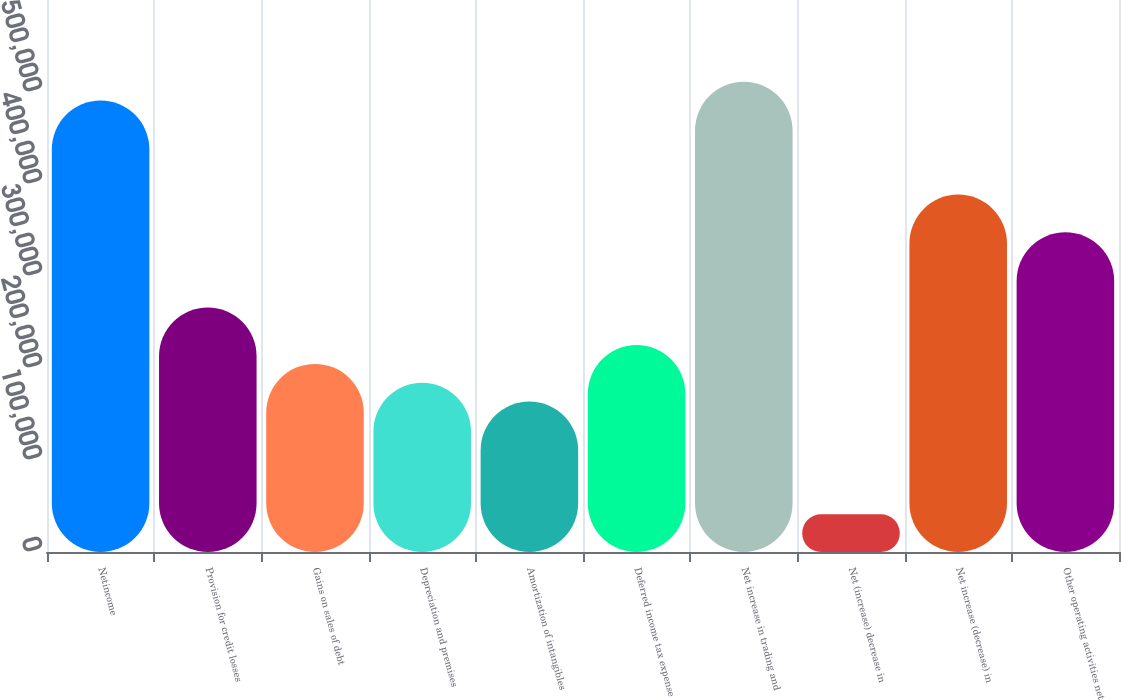Convert chart to OTSL. <chart><loc_0><loc_0><loc_500><loc_500><bar_chart><fcel>Netincome<fcel>Provision for credit losses<fcel>Gains on sales of debt<fcel>Depreciation and premises<fcel>Amortization of intangibles<fcel>Deferred income tax expense<fcel>Net increase in trading and<fcel>Net (increase) decrease in<fcel>Net increase (decrease) in<fcel>Other operating activities net<nl><fcel>490674<fcel>265804<fcel>204476<fcel>184033<fcel>163591<fcel>224919<fcel>511116<fcel>40934.4<fcel>388460<fcel>347575<nl></chart> 